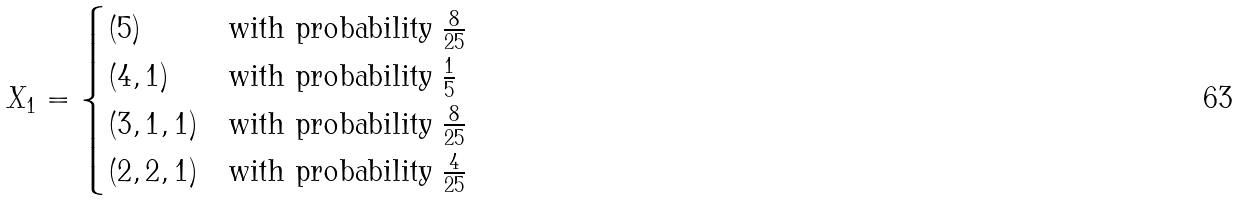Convert formula to latex. <formula><loc_0><loc_0><loc_500><loc_500>X _ { 1 } = \begin{cases} ( 5 ) & \text {with probability } \frac { 8 } { 2 5 } \\ ( 4 , 1 ) & \text {with probability } \frac { 1 } { 5 } \\ ( 3 , 1 , 1 ) & \text {with probability } \frac { 8 } { 2 5 } \\ ( 2 , 2 , 1 ) & \text {with probability } \frac { 4 } { 2 5 } \end{cases}</formula> 